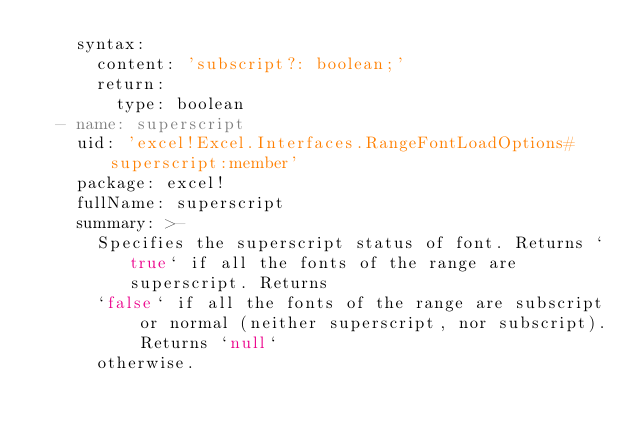Convert code to text. <code><loc_0><loc_0><loc_500><loc_500><_YAML_>    syntax:
      content: 'subscript?: boolean;'
      return:
        type: boolean
  - name: superscript
    uid: 'excel!Excel.Interfaces.RangeFontLoadOptions#superscript:member'
    package: excel!
    fullName: superscript
    summary: >-
      Specifies the superscript status of font. Returns `true` if all the fonts of the range are superscript. Returns
      `false` if all the fonts of the range are subscript or normal (neither superscript, nor subscript). Returns `null`
      otherwise.

</code> 